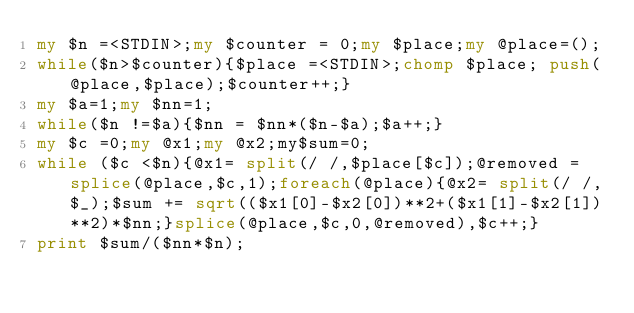Convert code to text. <code><loc_0><loc_0><loc_500><loc_500><_Perl_>my $n =<STDIN>;my $counter = 0;my $place;my @place=();
while($n>$counter){$place =<STDIN>;chomp $place; push(@place,$place);$counter++;}
my $a=1;my $nn=1;
while($n !=$a){$nn = $nn*($n-$a);$a++;}
my $c =0;my @x1;my @x2;my$sum=0;
while ($c <$n){@x1= split(/ /,$place[$c]);@removed = splice(@place,$c,1);foreach(@place){@x2= split(/ /,$_);$sum += sqrt(($x1[0]-$x2[0])**2+($x1[1]-$x2[1])**2)*$nn;}splice(@place,$c,0,@removed),$c++;}
print $sum/($nn*$n);</code> 